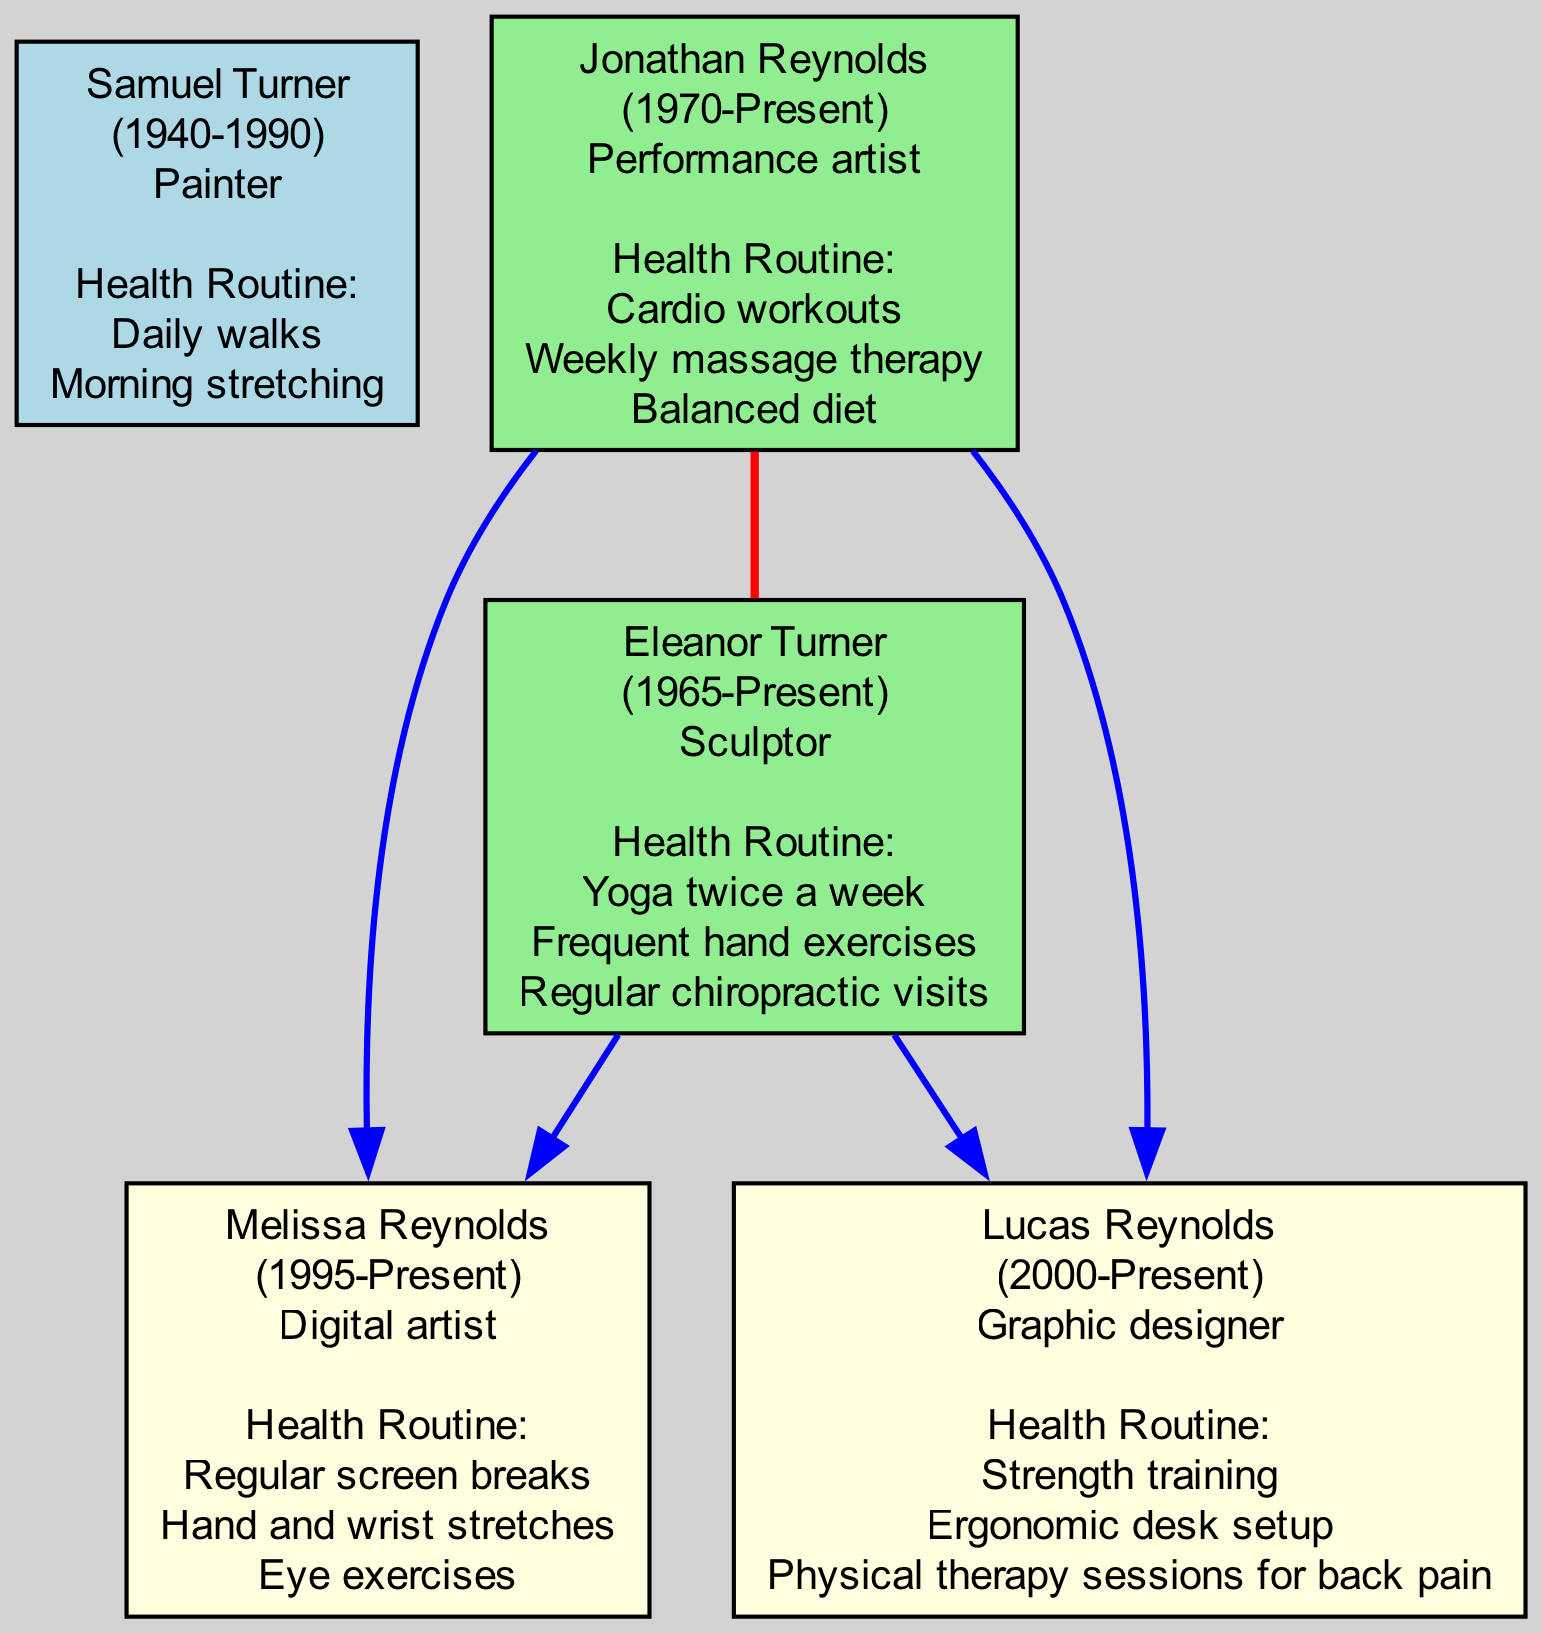What is the occupation of Samuel Turner? Samuel Turner is labeled in the diagram with his name, birth year, and occupation. The occupation listed for him is "Painter".
Answer: Painter How many generations are represented in the family tree? The family tree has five distinct individuals, each representing a different generation. Therefore, the number of generations is five.
Answer: Five Which health routine does Melissa Reynolds follow? The diagram sets out Melissa Reynolds' name along with her health routine. The listed activities include "Regular screen breaks", "Hand and wrist stretches", and "Eye exercises".
Answer: Regular screen breaks, hand and wrist stretches, eye exercises Who is Jonathan Reynolds married to? In the diagram, Jonathan Reynolds is shown with a direct connection labeled "MarriedTo". This indicates his spouse, which is listed as "Eleanor Turner".
Answer: Eleanor Turner What year was Lucas Reynolds born? The diagram provides the birth year for each person. For Lucas Reynolds, the birth year indicated is "2000".
Answer: 2000 Which two artists share the same parents? By analyzing the connections in the diagram, both Melissa Reynolds and Lucas Reynolds are shown under the same parent category, which includes their parents named "Eleanor Turner" and "Jonathan Reynolds".
Answer: Melissa Reynolds and Lucas Reynolds What is the primary health concern for Lucas Reynolds reflected in his health routine? The health routine listed for Lucas Reynolds includes "Physical therapy sessions for back pain", highlighting his primary health concern as back pain.
Answer: Back pain Who in the family has a health routine involving yoga? By examining the health routines, Eleanor Turner has "Yoga twice a week" listed as part of her routine, making her the family member practicing yoga.
Answer: Eleanor Turner What is the relationship between Melissa Reynolds and Samuel Turner? Melissa Reynolds is part of the generational line that connects back to Samuel Turner. Melissa's parents, Eleanor Turner and Jonathan Reynolds, are the next generation, indicating that Samuel Turner is her grandparent.
Answer: Grandparent-grandchild 